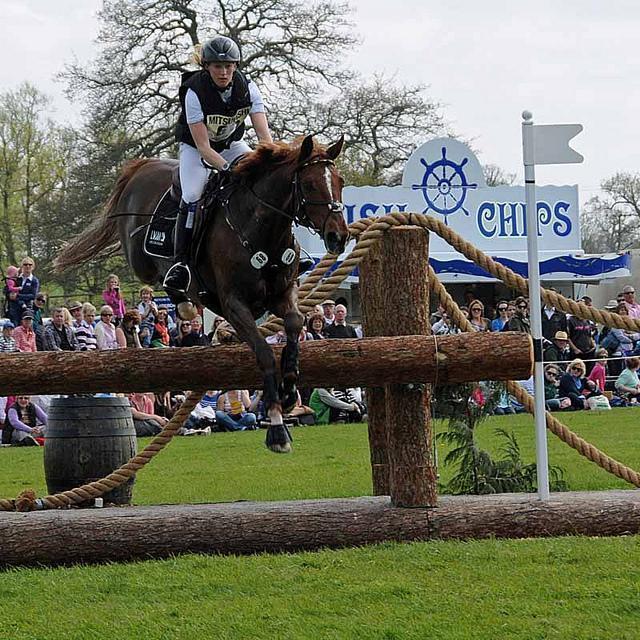What object is in the center of the chips stand logo?
Choose the correct response, then elucidate: 'Answer: answer
Rationale: rationale.'
Options: Ship, boat, wheel, potato. Answer: wheel.
Rationale: The logo has the characteristics and features of answer a. 